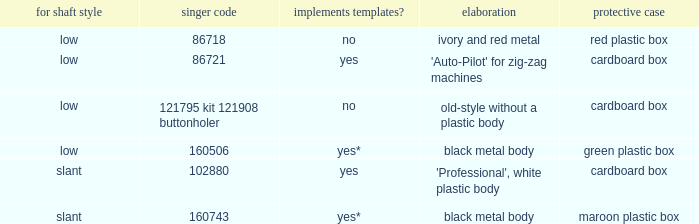What's the shank type of the buttonholer with red plastic box as storage case? Low. Could you help me parse every detail presented in this table? {'header': ['for shaft style', 'singer code', 'implements templates?', 'elaboration', 'protective case'], 'rows': [['low', '86718', 'no', 'ivory and red metal', 'red plastic box'], ['low', '86721', 'yes', "'Auto-Pilot' for zig-zag machines", 'cardboard box'], ['low', '121795 kit 121908 buttonholer', 'no', 'old-style without a plastic body', 'cardboard box'], ['low', '160506', 'yes*', 'black metal body', 'green plastic box'], ['slant', '102880', 'yes', "'Professional', white plastic body", 'cardboard box'], ['slant', '160743', 'yes*', 'black metal body', 'maroon plastic box']]} 